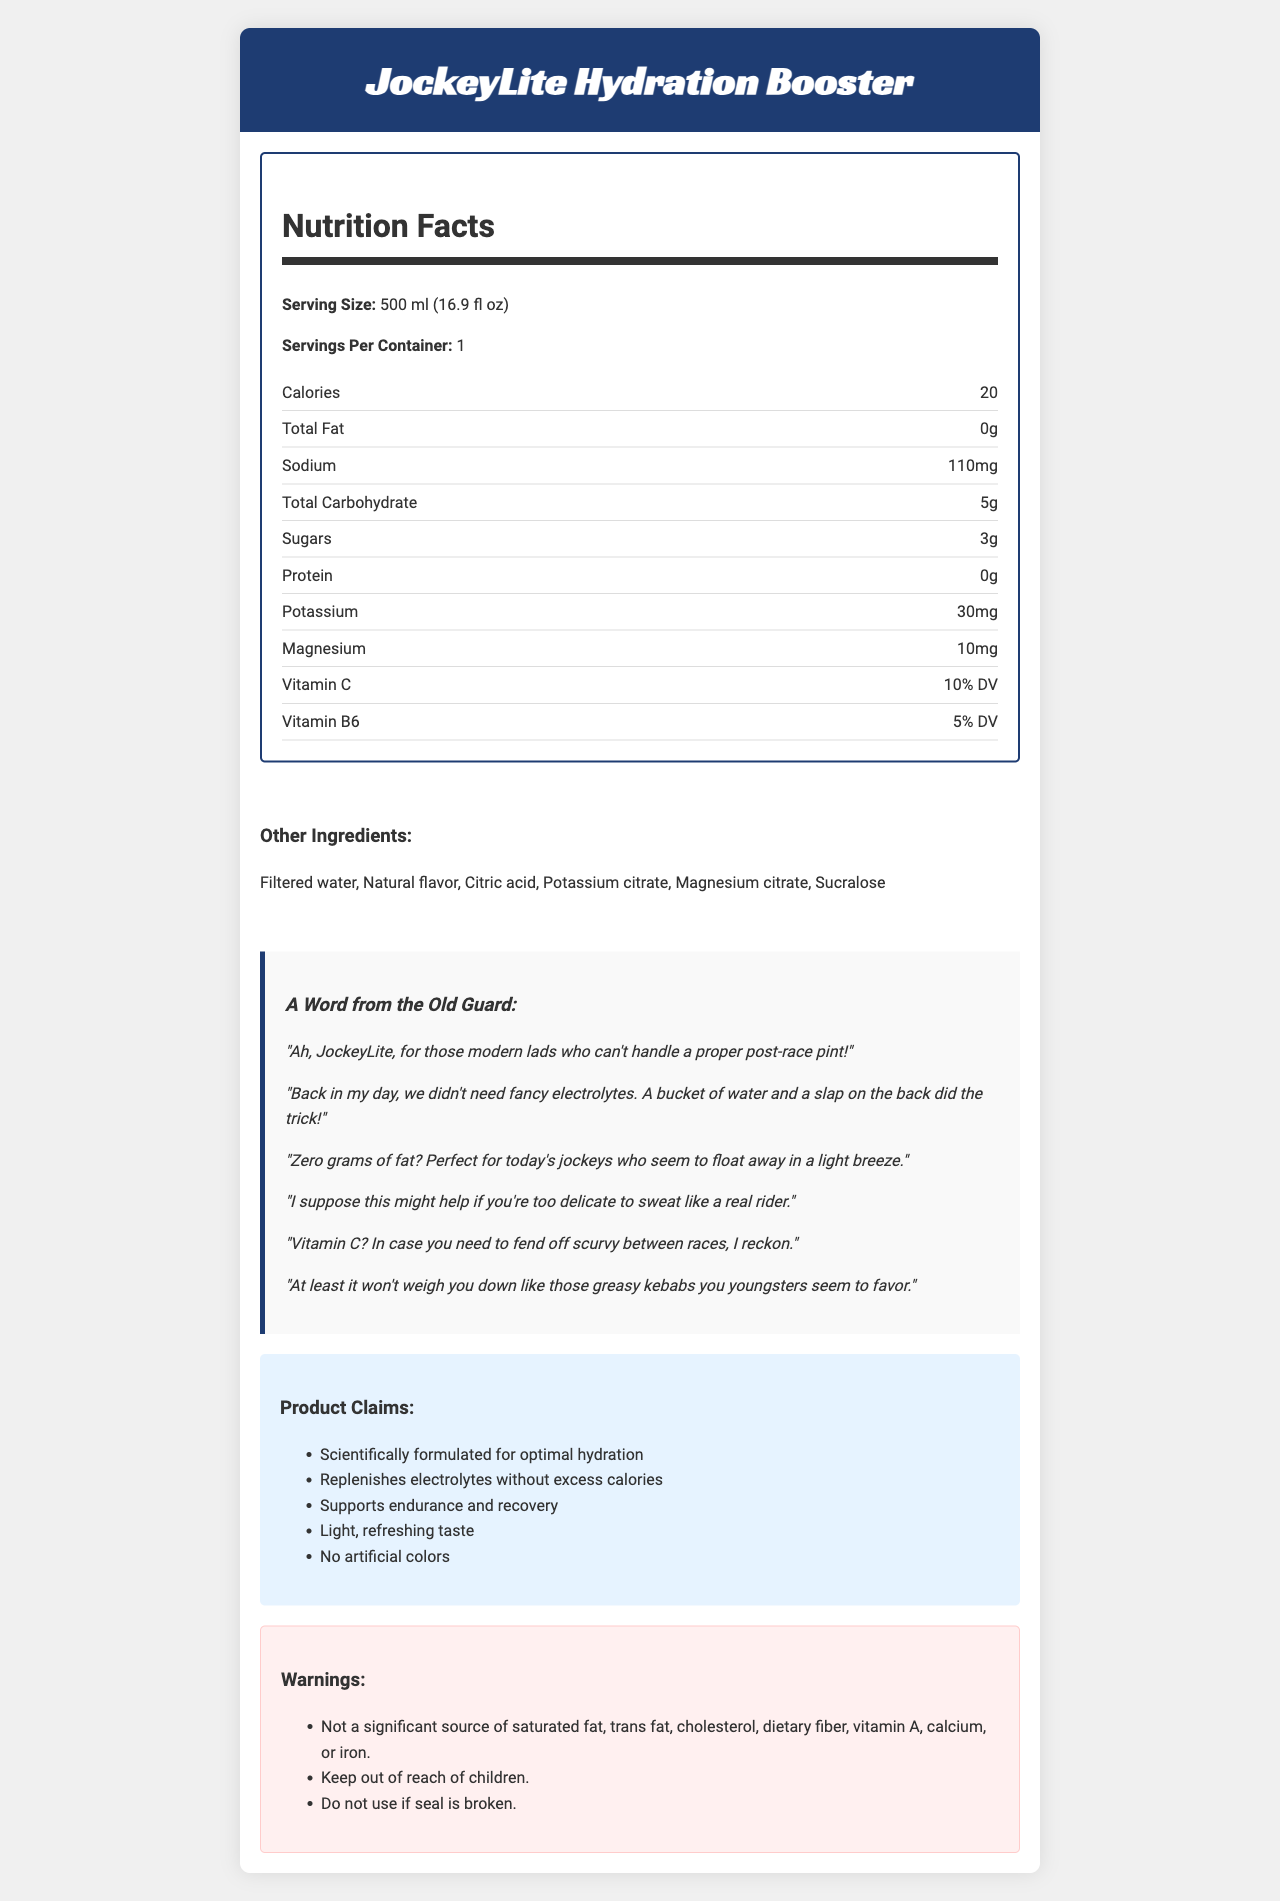what is the serving size of JockeyLite Hydration Booster? The serving size is explicitly listed in the nutrition facts section as "500 ml (16.9 fl oz)".
Answer: 500 ml (16.9 fl oz) how many calories are in one serving? The nutrition facts section states that there are 20 calories per serving.
Answer: 20 how much sodium does one serving contain? The nutrition facts section states that one serving contains 110mg of sodium.
Answer: 110mg what ingredients contribute to the flavor of the drink? The ingredients list includes "Natural flavor" and "Citric acid" which are typical flavoring agents.
Answer: Natural flavor, Citric acid which vitamins are mentioned on the nutrition label? The nutrition facts section lists Vitamin C (10% DV) and Vitamin B6 (5% DV).
Answer: Vitamin C and Vitamin B6 which ingredient is used as a sweetener in JockeyLite Hydration Booster? A. Sugar B. Aspartame C. Sucralose D. Stevia The ingredient list includes "Sucralose", a common artificial sweetener.
Answer: C why might a jockey in the past have scoffed at this drink? A. Lack of alcohol B. Presence of vitamins C. Low fat content D. Use of sucralose One of the jockey commentaries mentions modern athletes not needing fancy electrolytes and preferring a post-race pint, implying the lack of alcohol is a potential reason.
Answer: A is this drink significant in providing dietary fiber? The warnings section explicitly states that it is "Not a significant source of dietary fiber".
Answer: No how many grams of sugar are in one serving? The nutrition facts section lists that there are 3 grams of sugar in one serving.
Answer: 3g describe the main idea of the document. The document includes a balance between serious nutritional information and playful commentary from an experienced jockey. It details the drink's composition, nutritional benefits, and marketing points, along with warnings.
Answer: The document provides nutritional information about "JockeyLite Hydration Booster", highlighting its low-calorie content, essential electrolytes, and vitamins, while also including some marketing claims and warnings. It features a sarcastic commentary from an old-school jockey, emphasizing traditional values. what makes this drink "scientifically formulated"? The term "scientifically formulated" appears in the marketing claims, but the document does not provide any specific scientific studies or formulations to verify the claim.
Answer: Not enough information 